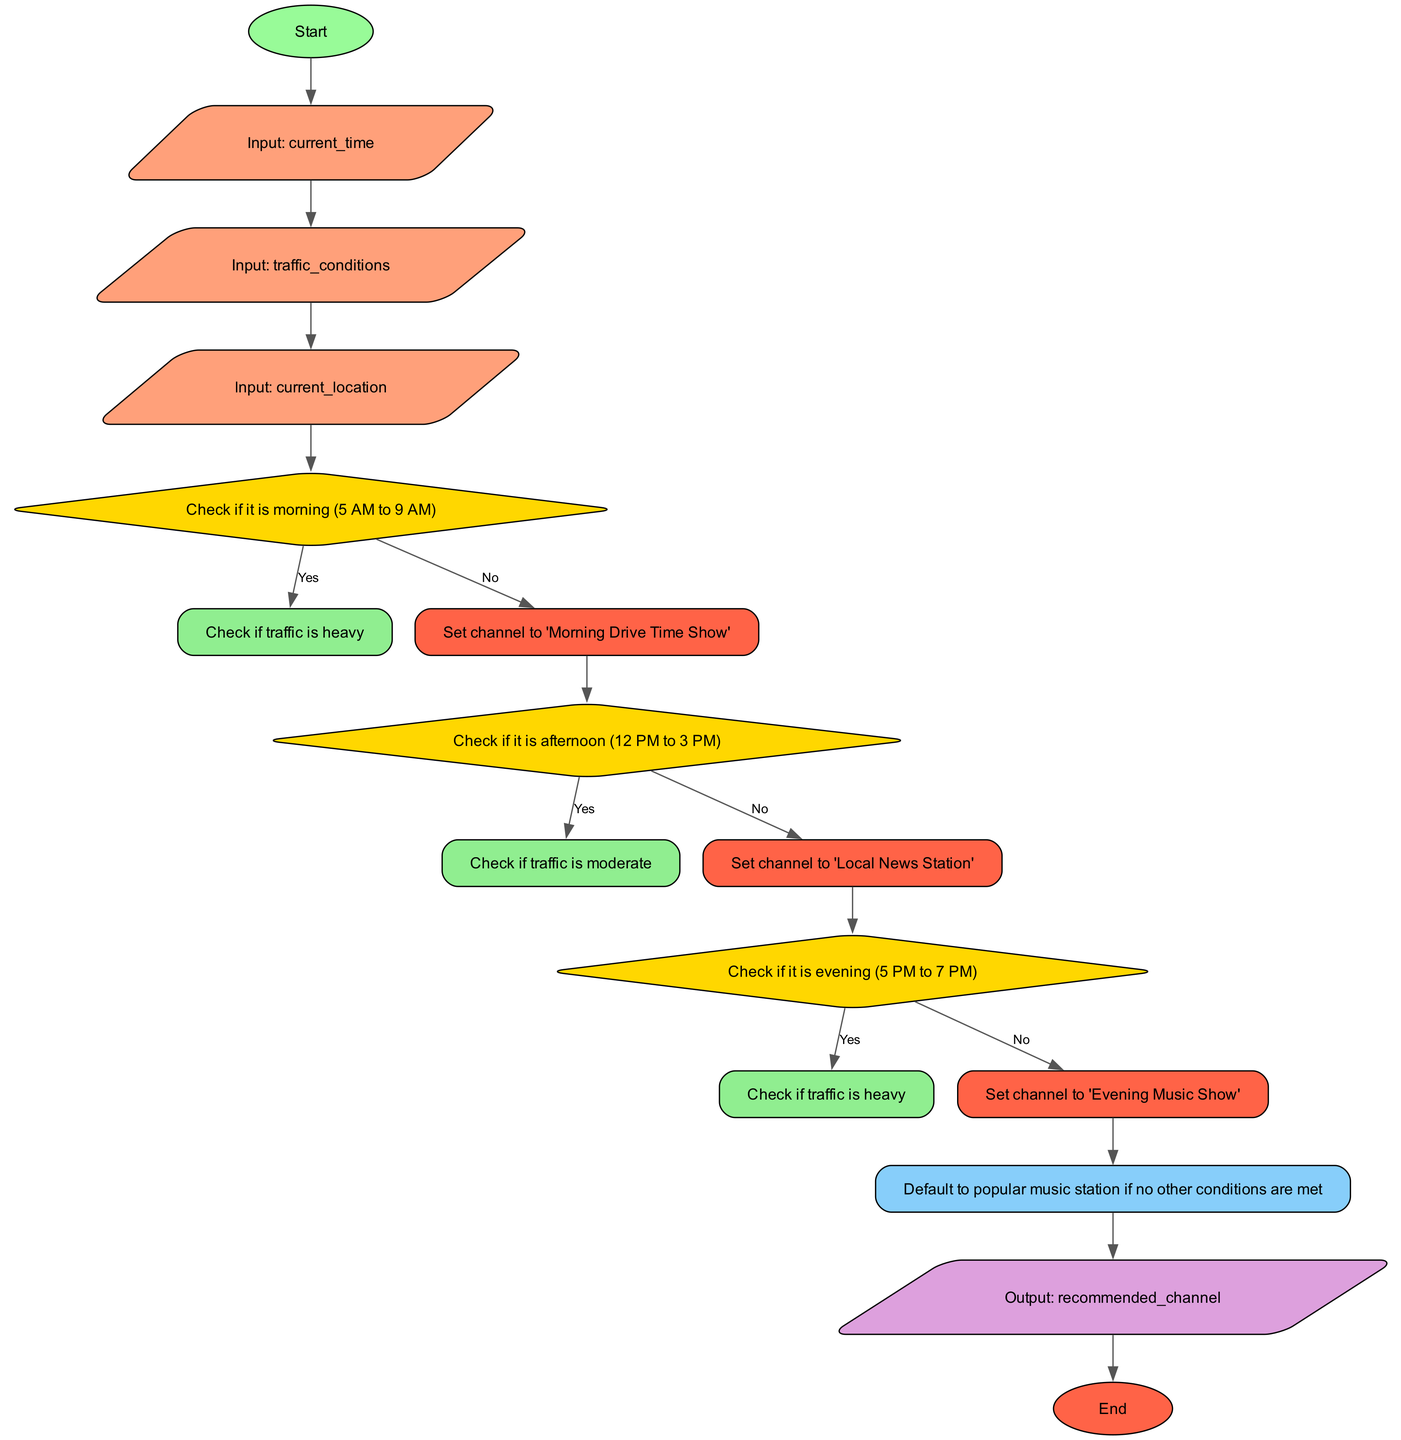What's the output node in this flowchart? The output node is defined as the final output of the function, which is labeled as "Output: recommended_channel". This is the node that indicates what the function ultimately returns based on the inputs provided.
Answer: Output: recommended_channel How many input nodes are there in the flowchart? The flowchart lists three inputs: current_time, traffic_conditions, and current_location. Each of these is represented as a separate input node, totaling three input nodes.
Answer: 3 What is the channel set for heavy traffic in the morning? The process outlines that if it is morning and traffic is heavy, the channel is set to "Traffic and Weather on the 8s". This outcome is determined by the specific condition checks within the flowchart.
Answer: Traffic and Weather on the 8s If it is afternoon and traffic is light, what channel do you end up with? The flowchart specifies that during the afternoon, if traffic is not moderate (which implies it is light or absent), the channel would be set to "Local News Station". This channel would be chosen based on the specified conditions in the flowchart.
Answer: Local News Station How many steps are in the decision-making process? The flowchart contains four main steps: checking morning, afternoon, evening conditions, and a default action if none match. Each step plays a key role in determining the flow from input to output, so the total count of these decision-making steps is four.
Answer: 4 What is the label of the end node in the flowchart? The flowchart ends with a node labeled "End", which is typically used to indicate the termination of the process. This end node follows the output node, completing the flow of the function logically.
Answer: End What happens if it is evening and traffic is not heavy? The flowchart indicates that if it is evening and traffic is not heavy, the channel will be set to "Evening Music Show". This outcome is reached through the specific condition checks for the evening period.
Answer: Evening Music Show What type of flowchart structure is used? The flowchart follows a structured decision-making layout characterized by nodes and edges representing different conditions and their outcomes. Specifically, it uses a logical flow from inputs through conditions and decisions to output, which is typical for a process flowchart.
Answer: Decision-making layout 